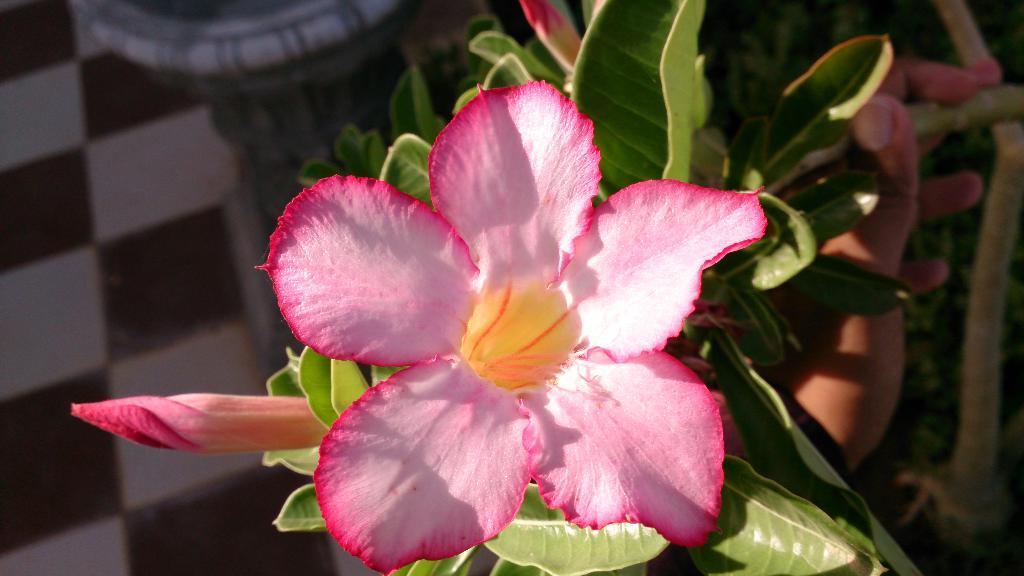Please provide a concise description of this image. In this image in the front there is a flower and in the background there are leaves and there is the hand of the person holding a plant. 